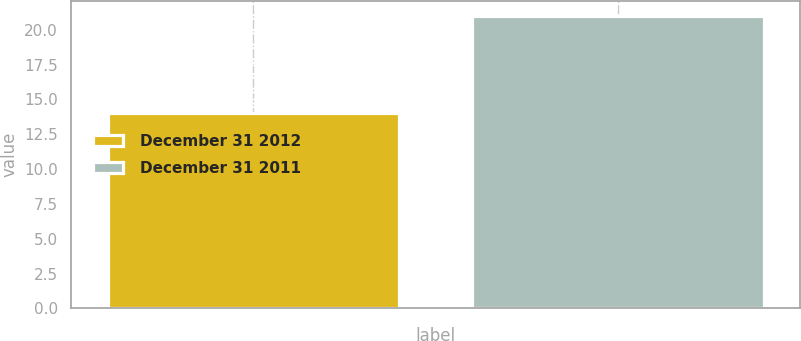Convert chart to OTSL. <chart><loc_0><loc_0><loc_500><loc_500><bar_chart><fcel>December 31 2012<fcel>December 31 2011<nl><fcel>14<fcel>21<nl></chart> 